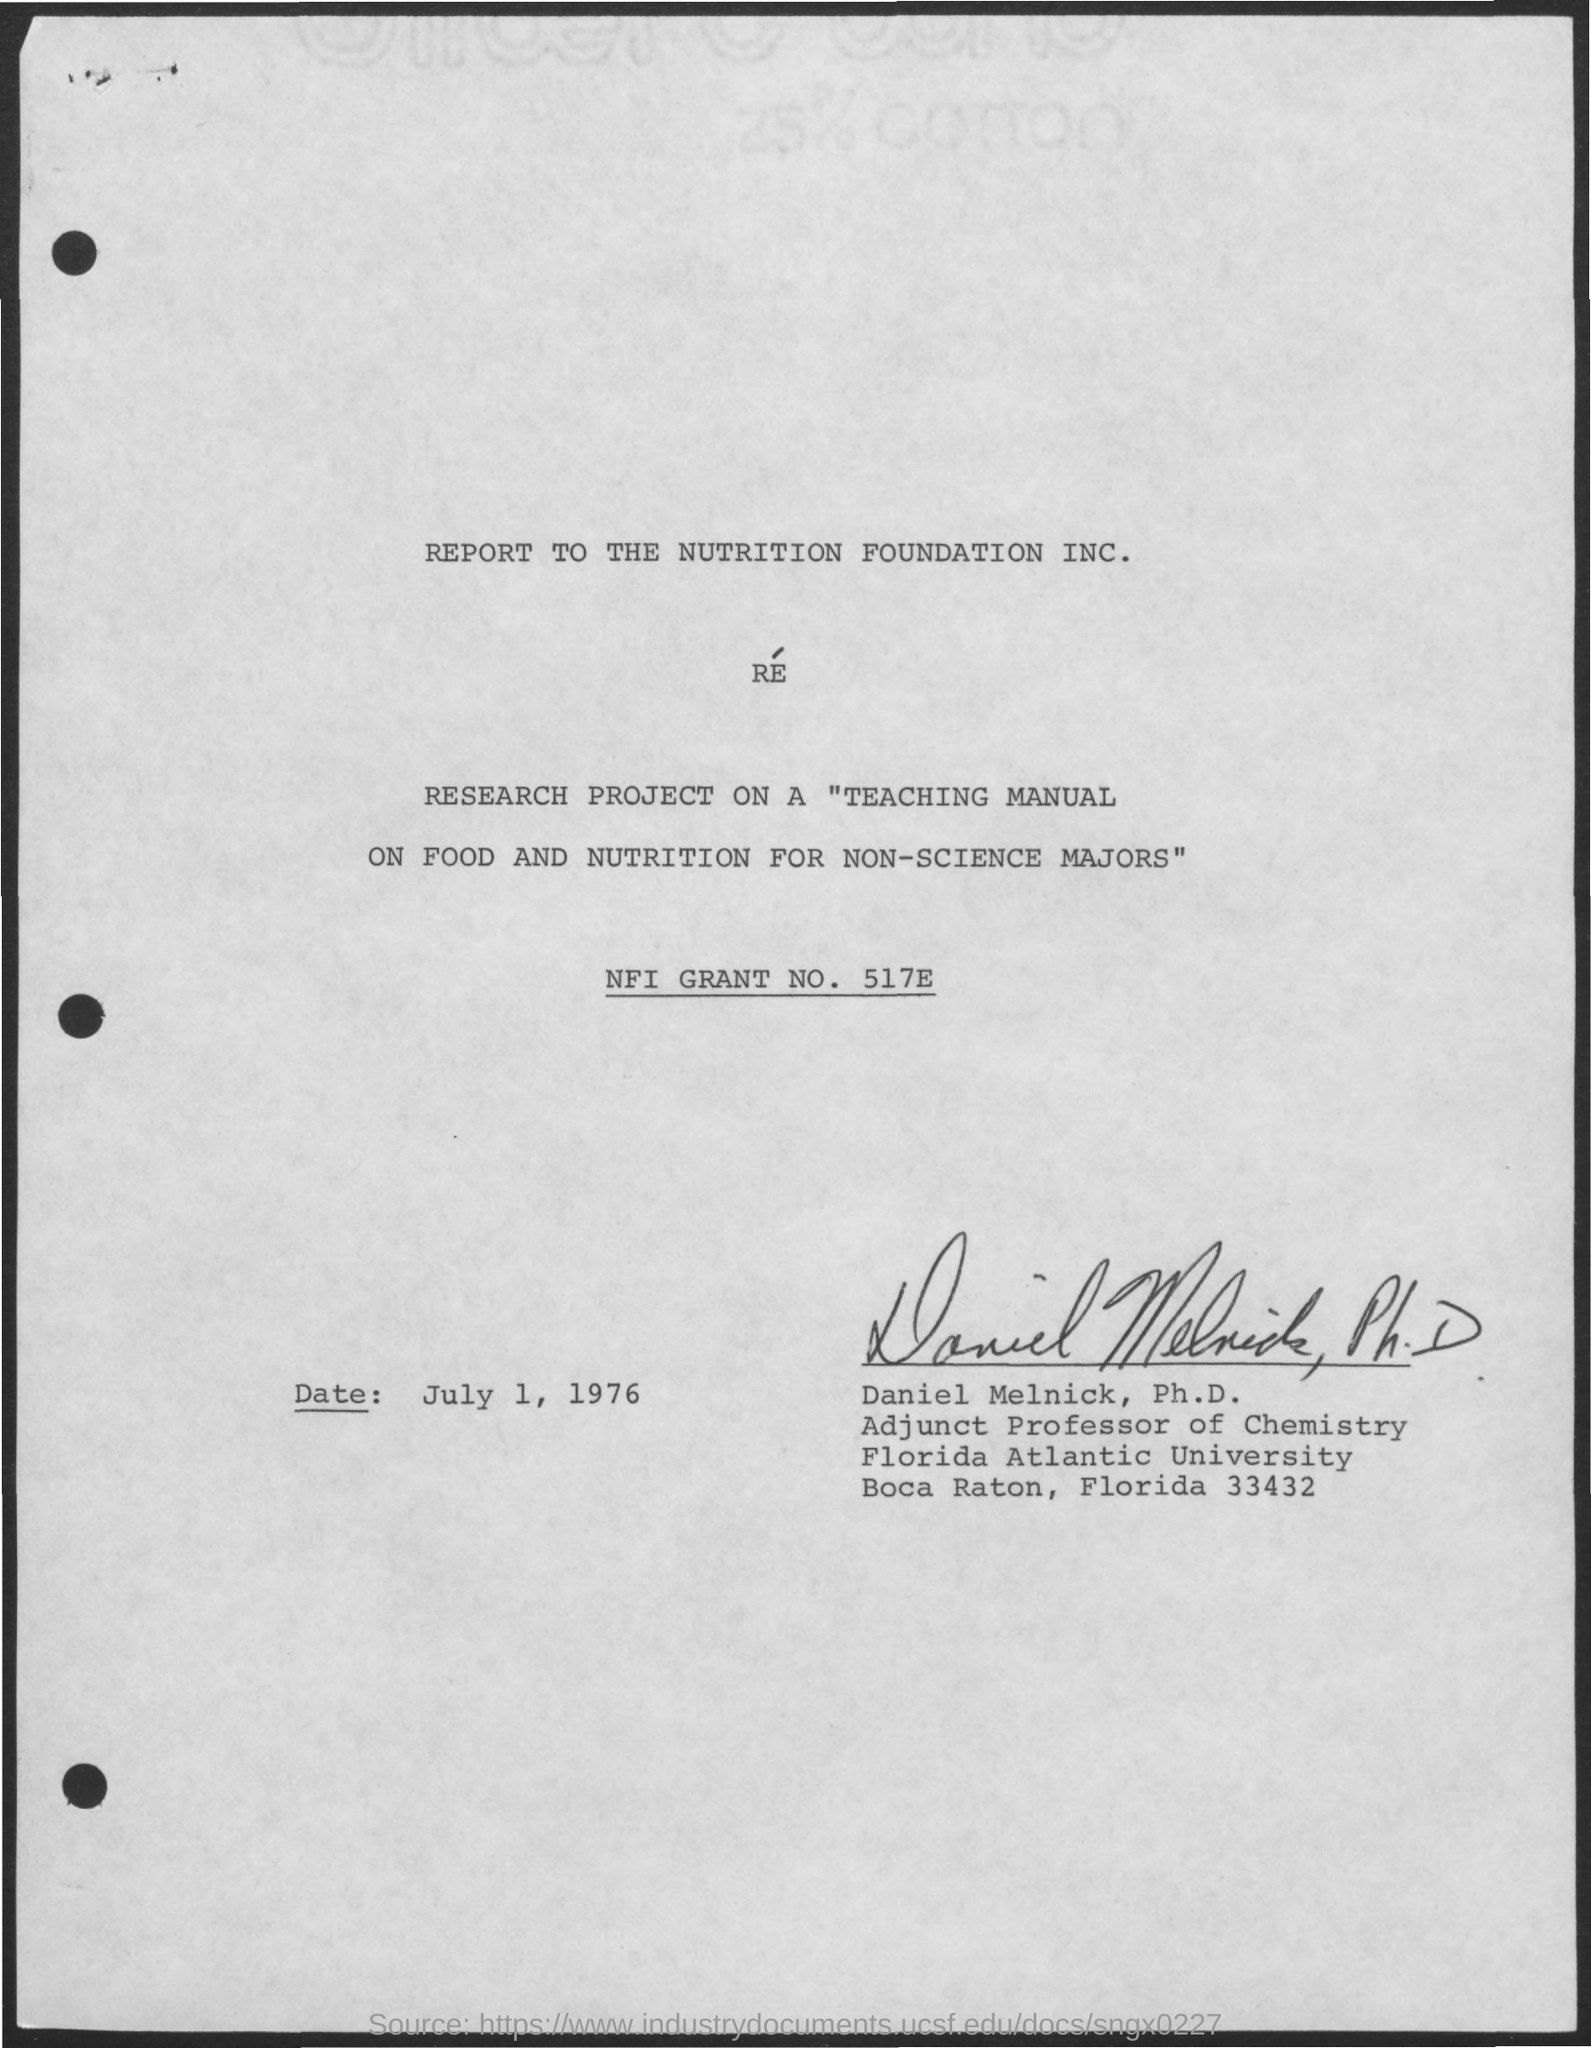What is the nfi grant no. ?
Provide a succinct answer. 517E. To whom is this report submitted?
Provide a short and direct response. The Nutrition Foundation Inc. What is the name of the project mentioned in the given page ?
Your response must be concise. Teaching Manual On Food And Nutrition for Non-science Majors. What is the date mentioned in the given page ?
Provide a succinct answer. July 1 , 1976. Who's sign was there at the end of the page ?
Provide a succinct answer. Daniel Melnick. What is the designation of daniel melnick mentioned in the given page ?
Keep it short and to the point. Adjunct professor of chemistry. To which university daniel melnick belongs to ?
Provide a succinct answer. Florida Atlantic University. 